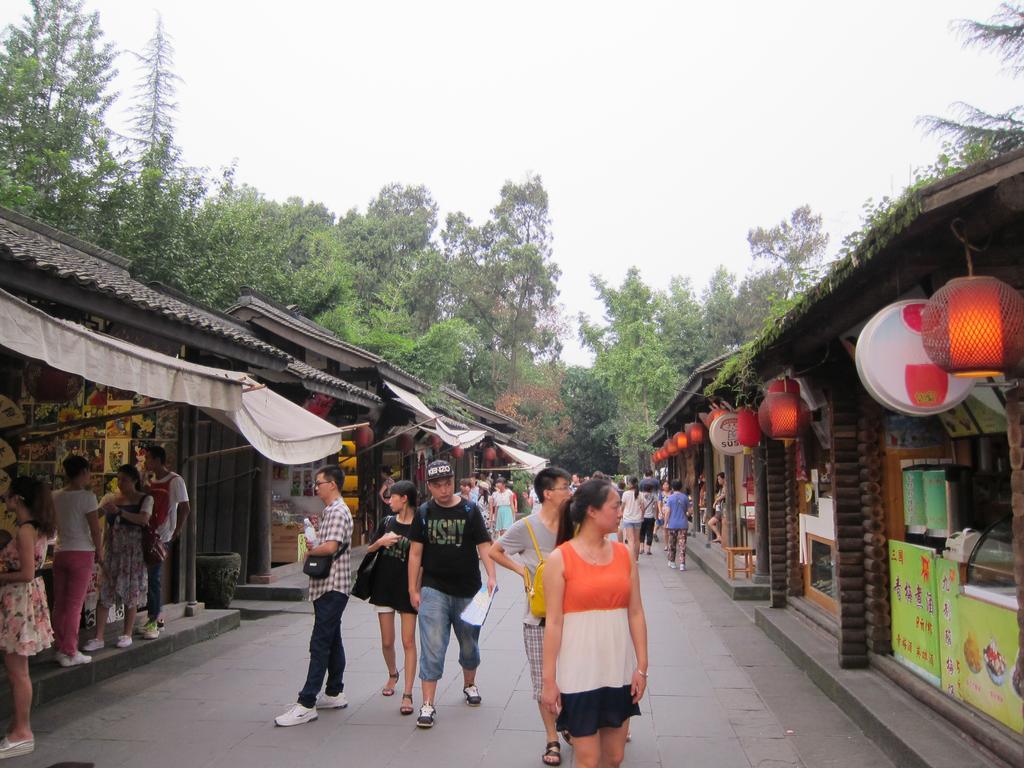Please provide a concise description of this image. In this image I can see few people are walking on the road. These people are wearing the different color dresses. To the side of these people I can see the houses and shops. And there are lights and boards can be seen to the shops. In the background I can see the trees and the white sky. 